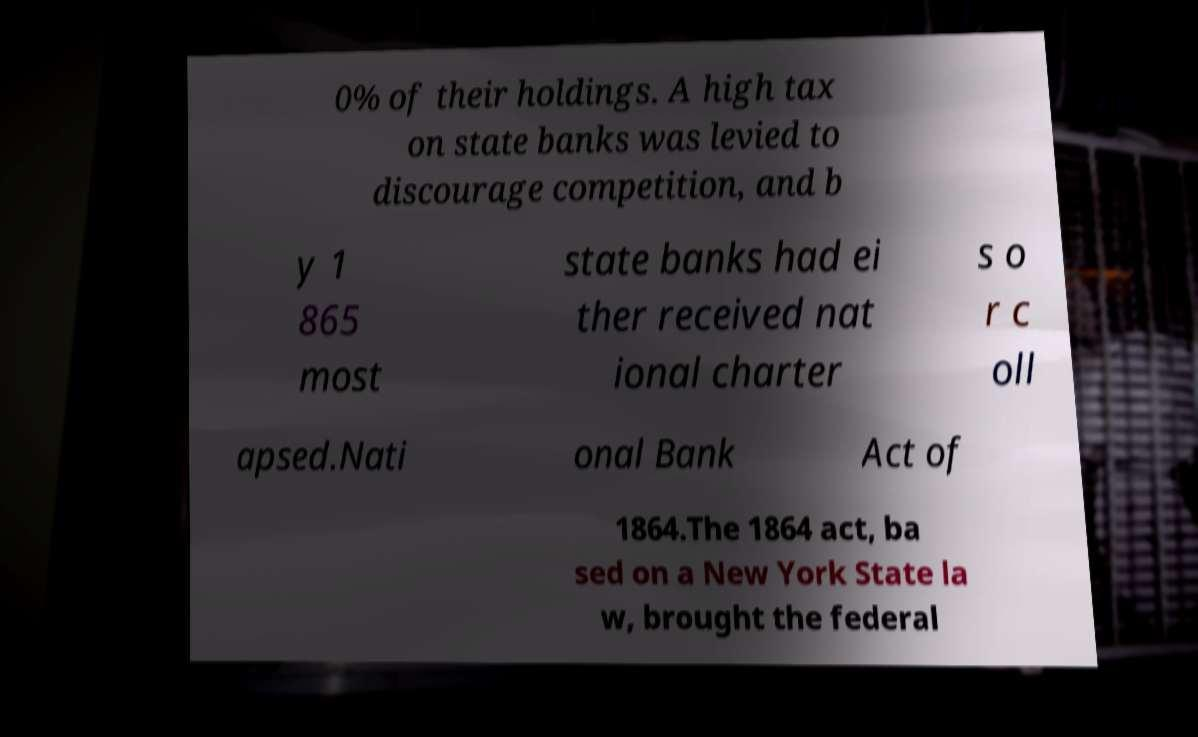There's text embedded in this image that I need extracted. Can you transcribe it verbatim? 0% of their holdings. A high tax on state banks was levied to discourage competition, and b y 1 865 most state banks had ei ther received nat ional charter s o r c oll apsed.Nati onal Bank Act of 1864.The 1864 act, ba sed on a New York State la w, brought the federal 